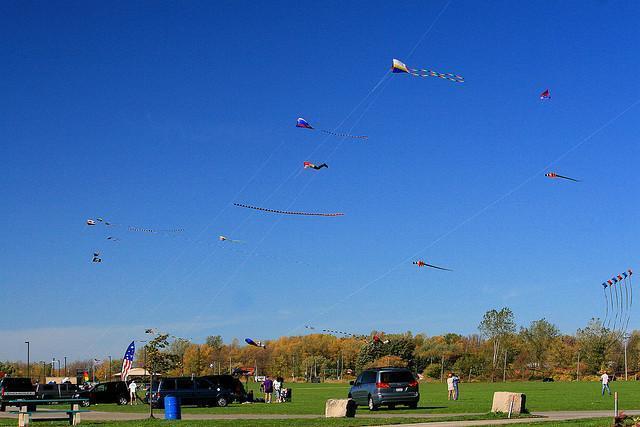How many cars are there?
Give a very brief answer. 1. How many trucks are in the picture?
Give a very brief answer. 1. 